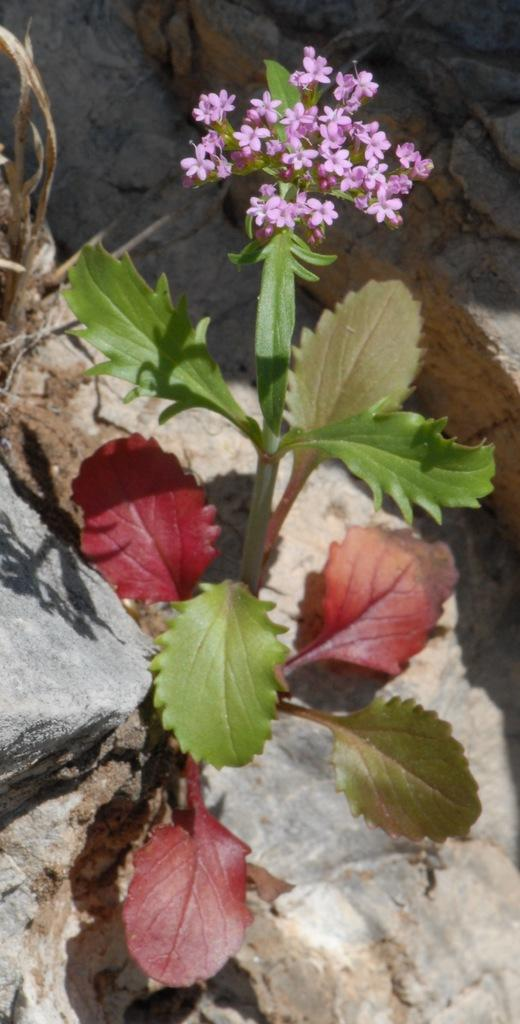What is the main subject in the center of the image? There is a flower plant in the center of the image. What can be seen at the bottom of the image? There are stones at the bottom of the image. What is the size of the insect on the flower in the image? There is no insect present on the flower in the image. 